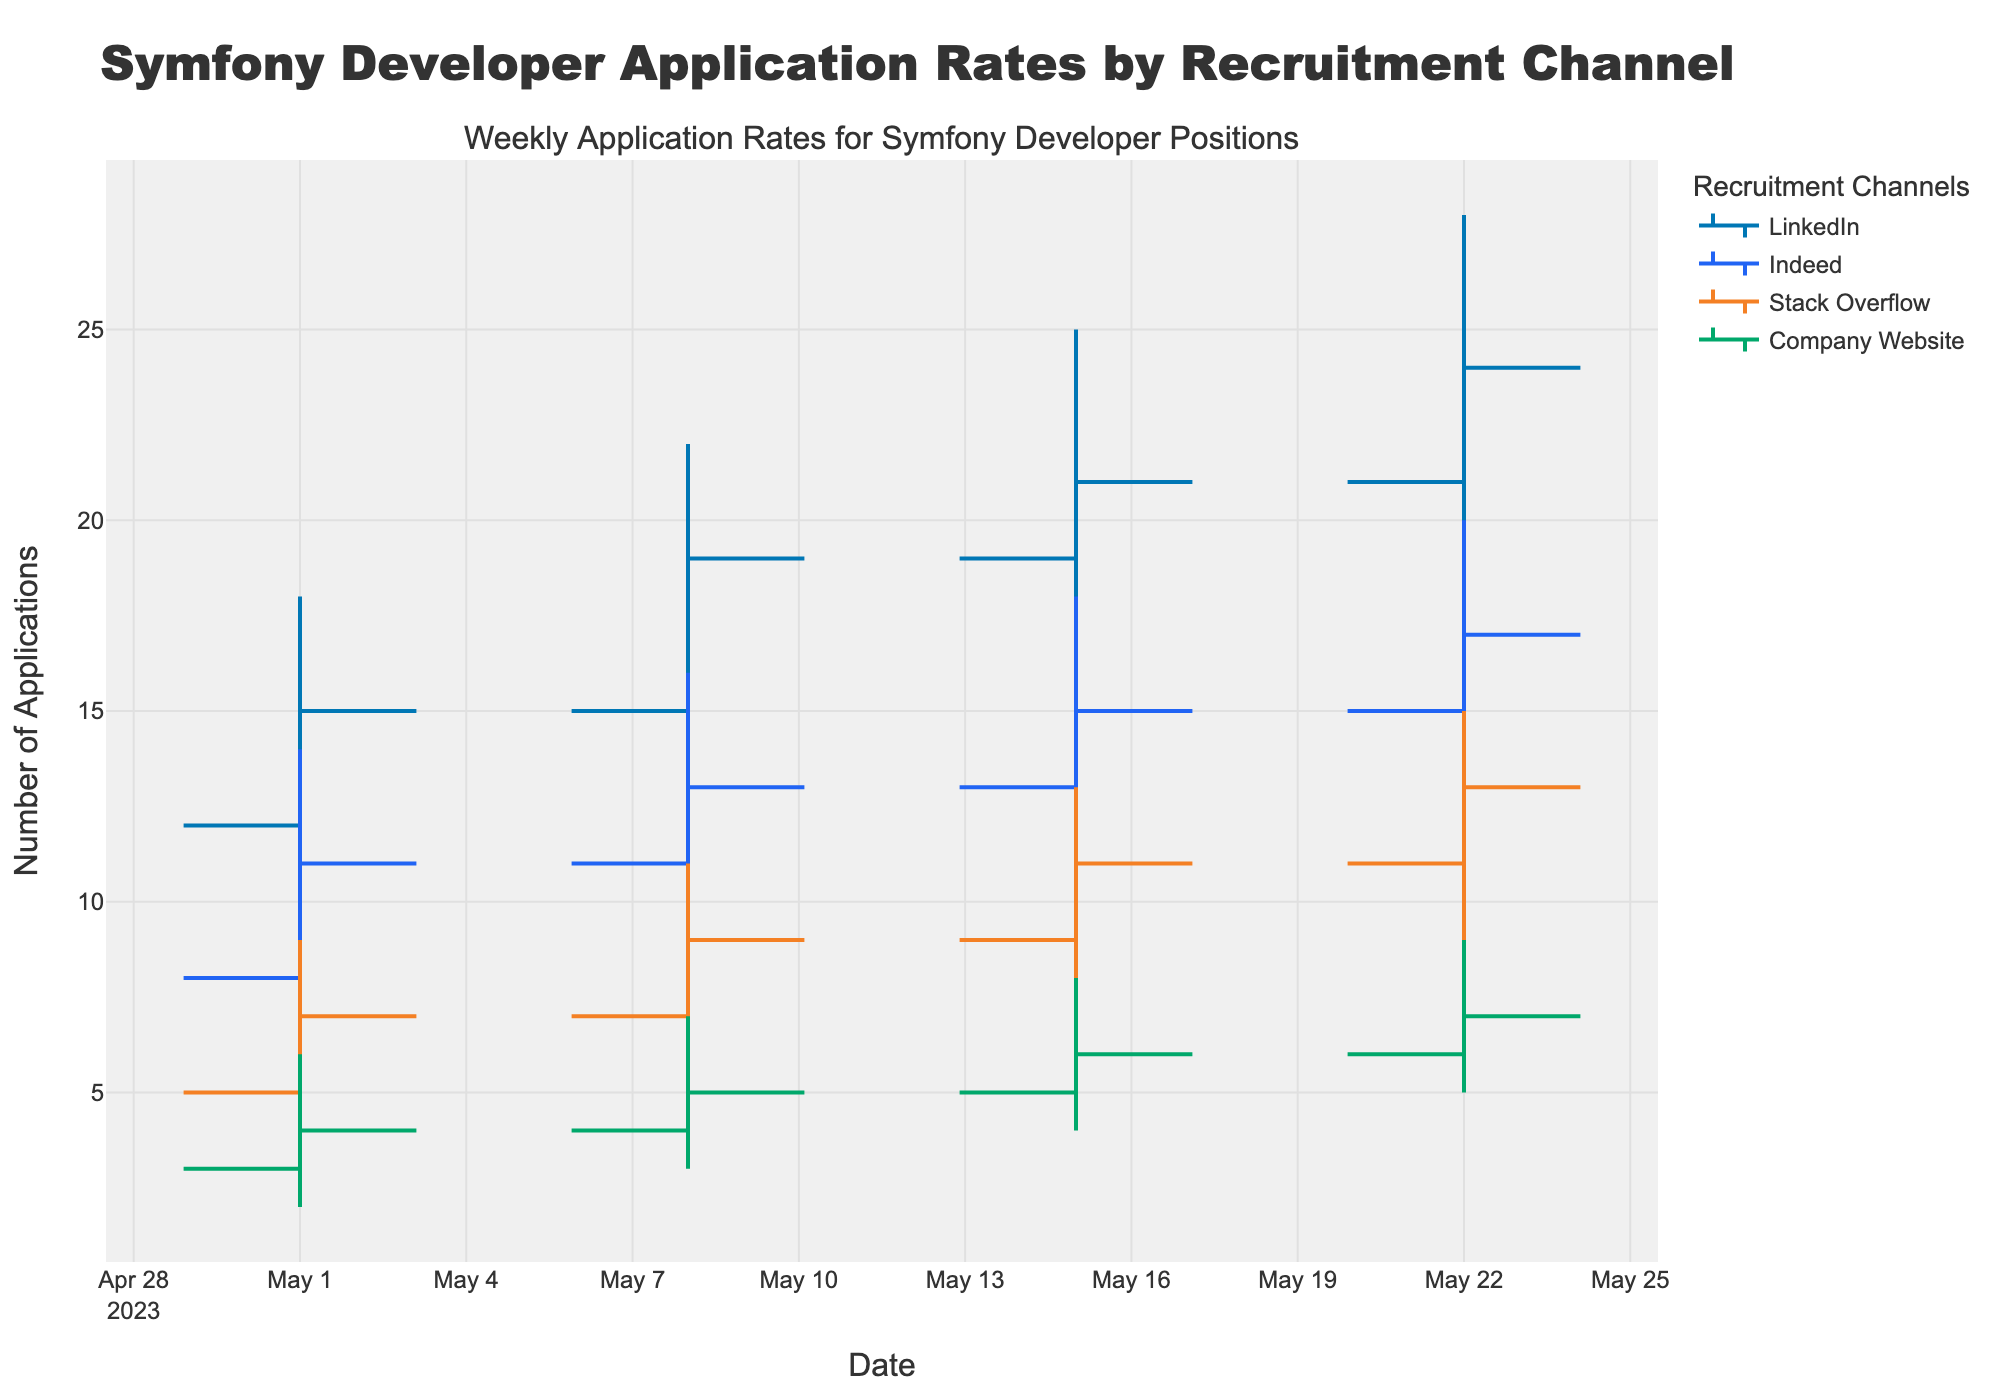what is the date range presented in the chart? The chart starts from May 1, 2023, and ends on May 22, 2023. Looking at the x-axis, the dates stretch across this defined range.
Answer: May 1, 2023, to May 22, 2023 Which recruitment channel saw the highest weekly application rate overall? By examining the highest points (High) on the OHLC chart, LinkedIn showed the highest weekly application rate at 28 applications on the week starting May 22, 2023. No other channel had a peak higher than this.
Answer: LinkedIn What was the lowest application rate for Stack Overflow and when did it occur? Looking at the lowest points (Low) for Stack Overflow, the chart shows it was 3 applications for the week starting May 1, 2023.
Answer: 3 applications on May 1, 2023 For which recruitment channel was the change in application rate from the first to the final week the most significant? To determine the most significant change, calculate the difference between the starting (Open) and the ending (Close) values for each channel. LinkedIn had the highest difference (24 - 12 = 12 applications).
Answer: LinkedIn During which week did Indeed have the largest range in application rates? The range is calculated by subtracting the Low from the High for each week. Indeed had its largest range on the week of May 22, 2023, with a range of (20 - 13 = 7).
Answer: May 22, 2023 Which week showed the most consistent application rates for the Company Website? Consistency is indicated by the smallest range (High - Low). For the Company Website, May 1, 2023, had the smallest range (6 - 2 = 4).
Answer: May 1, 2023 Between LinkedIn and Stack Overflow, which channel had a higher peak application rate on May 15, 2023? Compare the highest points (High) of both channels on May 15, 2023. LinkedIn peaked at 25 applications, while Stack Overflow peaked at 13.
Answer: LinkedIn What pattern is observed in the closing application rates for LinkedIn over the four weeks? Observing the closing rates for LinkedIn, there is a consistent increase: 15, 19, 21, and 24 applications. This indicates a steady upward trend.
Answer: Steady upward trend By how much did the lowest application rate for Indeed increase from the first to the fourth week? The lowest application rate for Indeed on May 1, 2023, was 7, and it increased to 13 by May 22, 2023. The difference is 13 - 7 = 6 applications.
Answer: 6 applications Comparing May 8 and May 15, did any channel decrease in the highest application rate? If so, which one? Examining the highest points (High) for each channel on May 8 and May 15, no channel shows a decrease in the highest application rate. They either increased or stayed the same.
Answer: No channel 